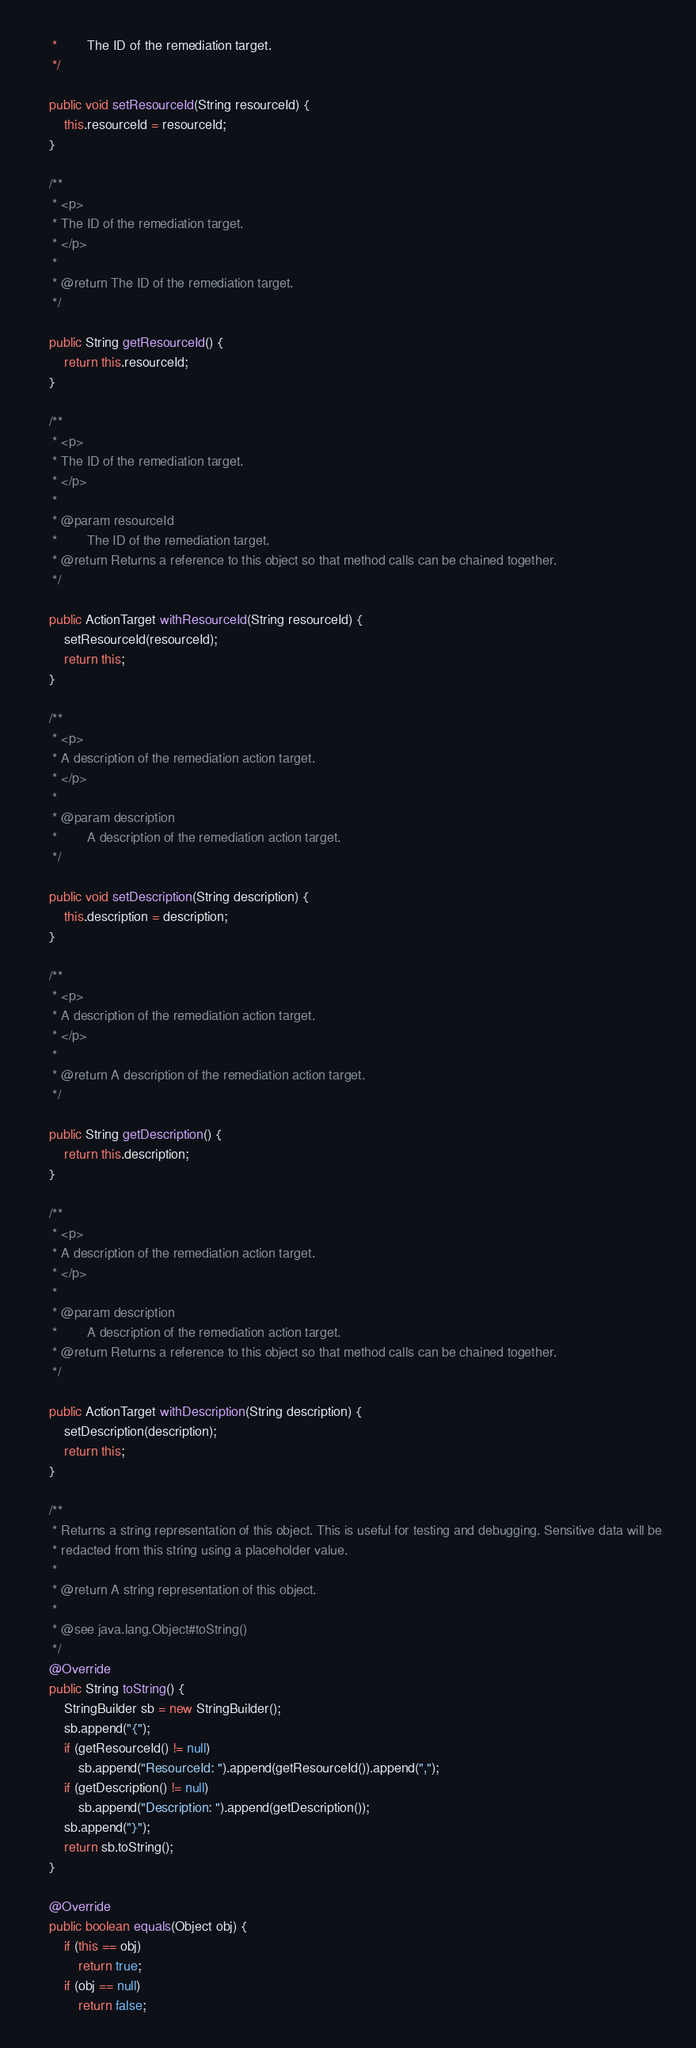<code> <loc_0><loc_0><loc_500><loc_500><_Java_>     *        The ID of the remediation target.
     */

    public void setResourceId(String resourceId) {
        this.resourceId = resourceId;
    }

    /**
     * <p>
     * The ID of the remediation target.
     * </p>
     * 
     * @return The ID of the remediation target.
     */

    public String getResourceId() {
        return this.resourceId;
    }

    /**
     * <p>
     * The ID of the remediation target.
     * </p>
     * 
     * @param resourceId
     *        The ID of the remediation target.
     * @return Returns a reference to this object so that method calls can be chained together.
     */

    public ActionTarget withResourceId(String resourceId) {
        setResourceId(resourceId);
        return this;
    }

    /**
     * <p>
     * A description of the remediation action target.
     * </p>
     * 
     * @param description
     *        A description of the remediation action target.
     */

    public void setDescription(String description) {
        this.description = description;
    }

    /**
     * <p>
     * A description of the remediation action target.
     * </p>
     * 
     * @return A description of the remediation action target.
     */

    public String getDescription() {
        return this.description;
    }

    /**
     * <p>
     * A description of the remediation action target.
     * </p>
     * 
     * @param description
     *        A description of the remediation action target.
     * @return Returns a reference to this object so that method calls can be chained together.
     */

    public ActionTarget withDescription(String description) {
        setDescription(description);
        return this;
    }

    /**
     * Returns a string representation of this object. This is useful for testing and debugging. Sensitive data will be
     * redacted from this string using a placeholder value.
     *
     * @return A string representation of this object.
     *
     * @see java.lang.Object#toString()
     */
    @Override
    public String toString() {
        StringBuilder sb = new StringBuilder();
        sb.append("{");
        if (getResourceId() != null)
            sb.append("ResourceId: ").append(getResourceId()).append(",");
        if (getDescription() != null)
            sb.append("Description: ").append(getDescription());
        sb.append("}");
        return sb.toString();
    }

    @Override
    public boolean equals(Object obj) {
        if (this == obj)
            return true;
        if (obj == null)
            return false;
</code> 